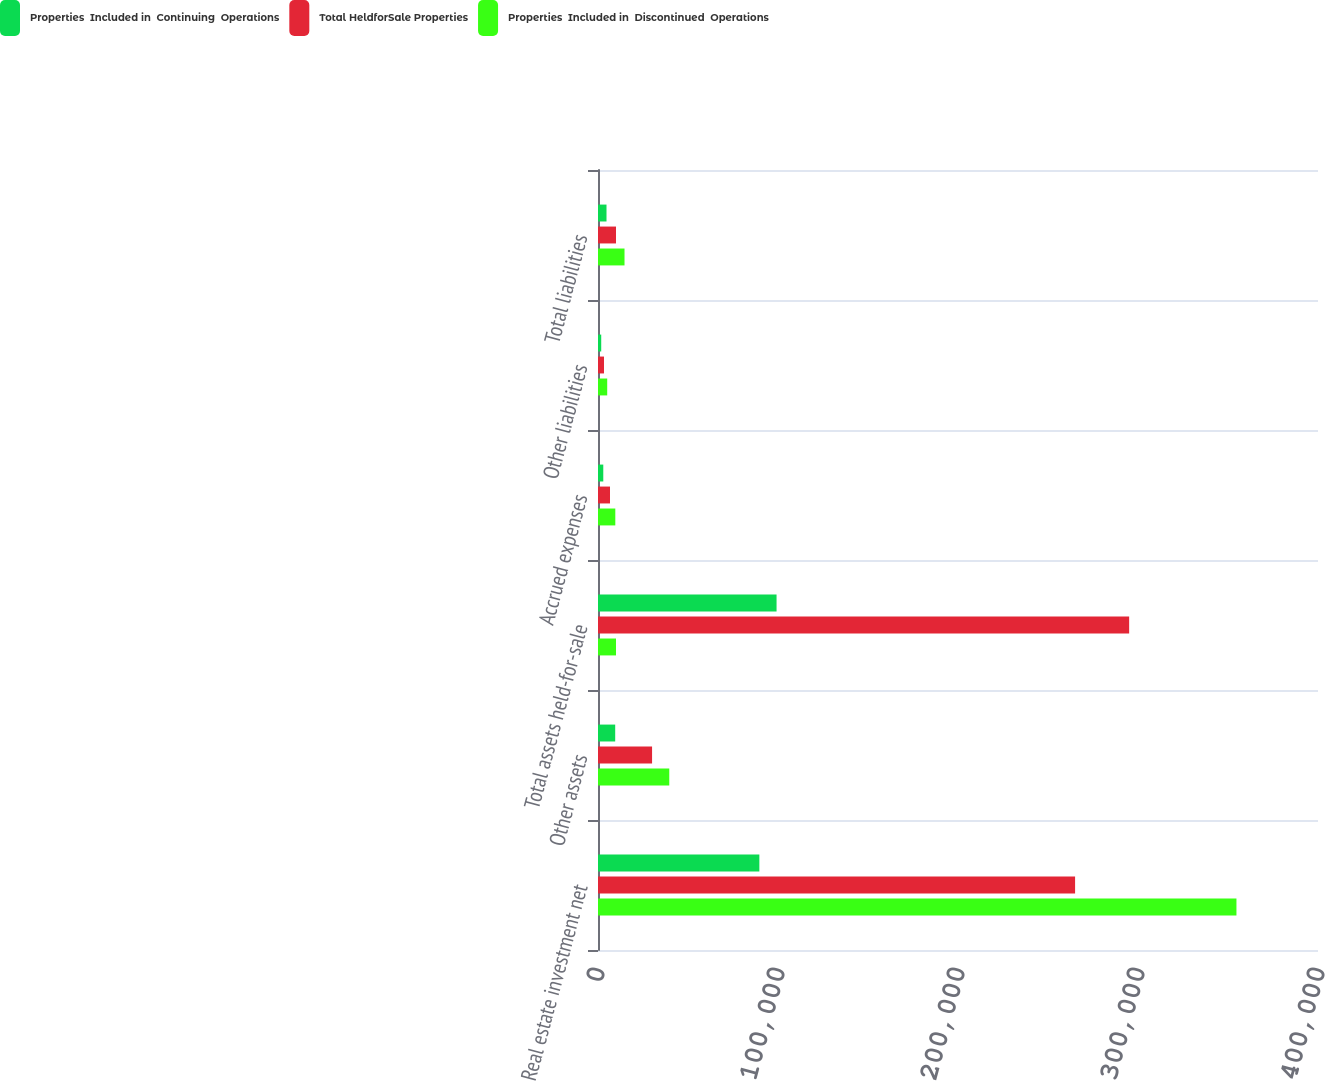Convert chart to OTSL. <chart><loc_0><loc_0><loc_500><loc_500><stacked_bar_chart><ecel><fcel>Real estate investment net<fcel>Other assets<fcel>Total assets held-for-sale<fcel>Accrued expenses<fcel>Other liabilities<fcel>Total liabilities<nl><fcel>Properties  Included in  Continuing  Operations<fcel>89643<fcel>9557<fcel>99200<fcel>2936<fcel>1789<fcel>4725<nl><fcel>Total HeldforSale Properties<fcel>265049<fcel>30038<fcel>295087<fcel>6679<fcel>3328<fcel>10007<nl><fcel>Properties  Included in  Discontinued  Operations<fcel>354692<fcel>39595<fcel>10007<fcel>9615<fcel>5117<fcel>14732<nl></chart> 